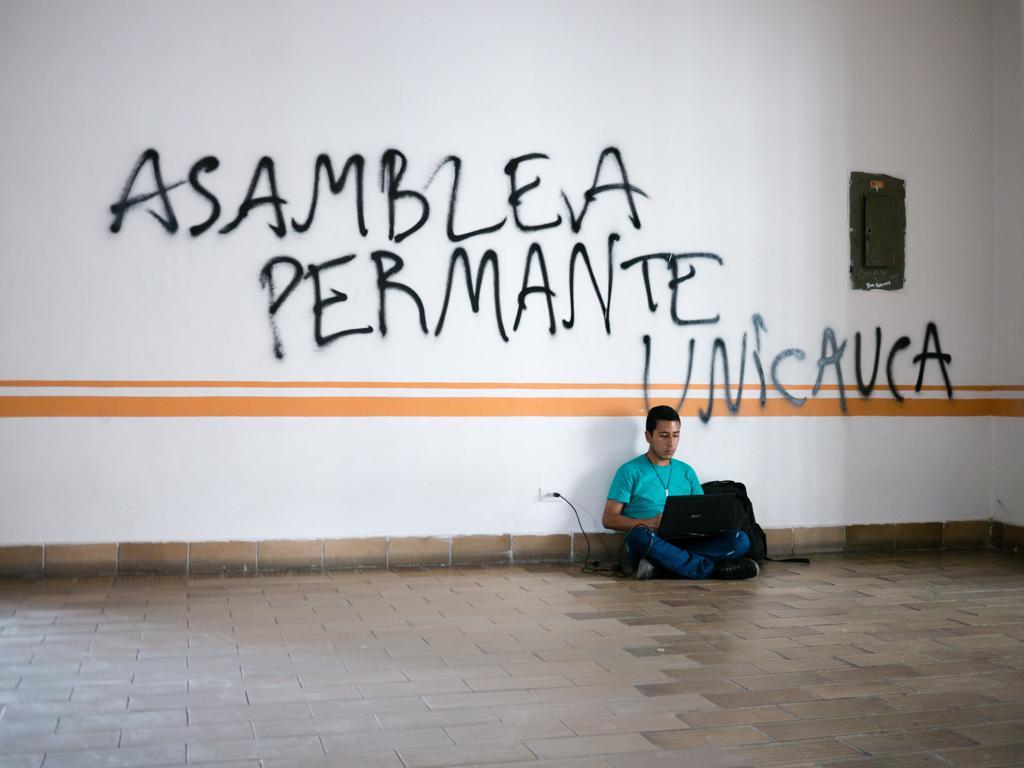Can you describe this image briefly? In this picture there is a boy who is sitting on the floor, on the right side of the image, he is operating a laptop and there is a box on the wall, on the right side of the image. 